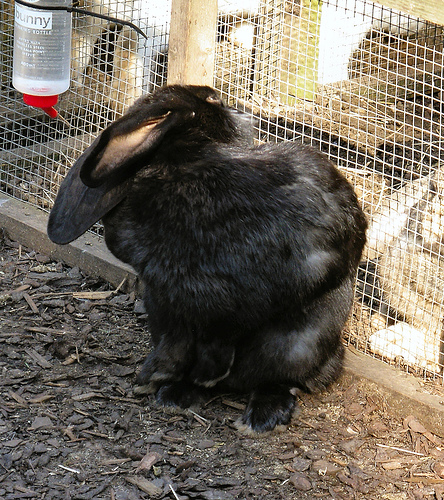<image>
Can you confirm if the rabbit is in the cage? Yes. The rabbit is contained within or inside the cage, showing a containment relationship. 